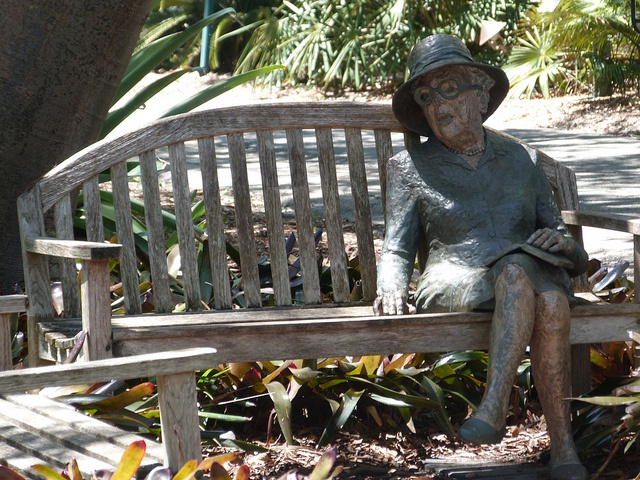Describe the objects in this image and their specific colors. I can see bench in black, gray, and white tones and bench in black, gray, white, and darkgray tones in this image. 